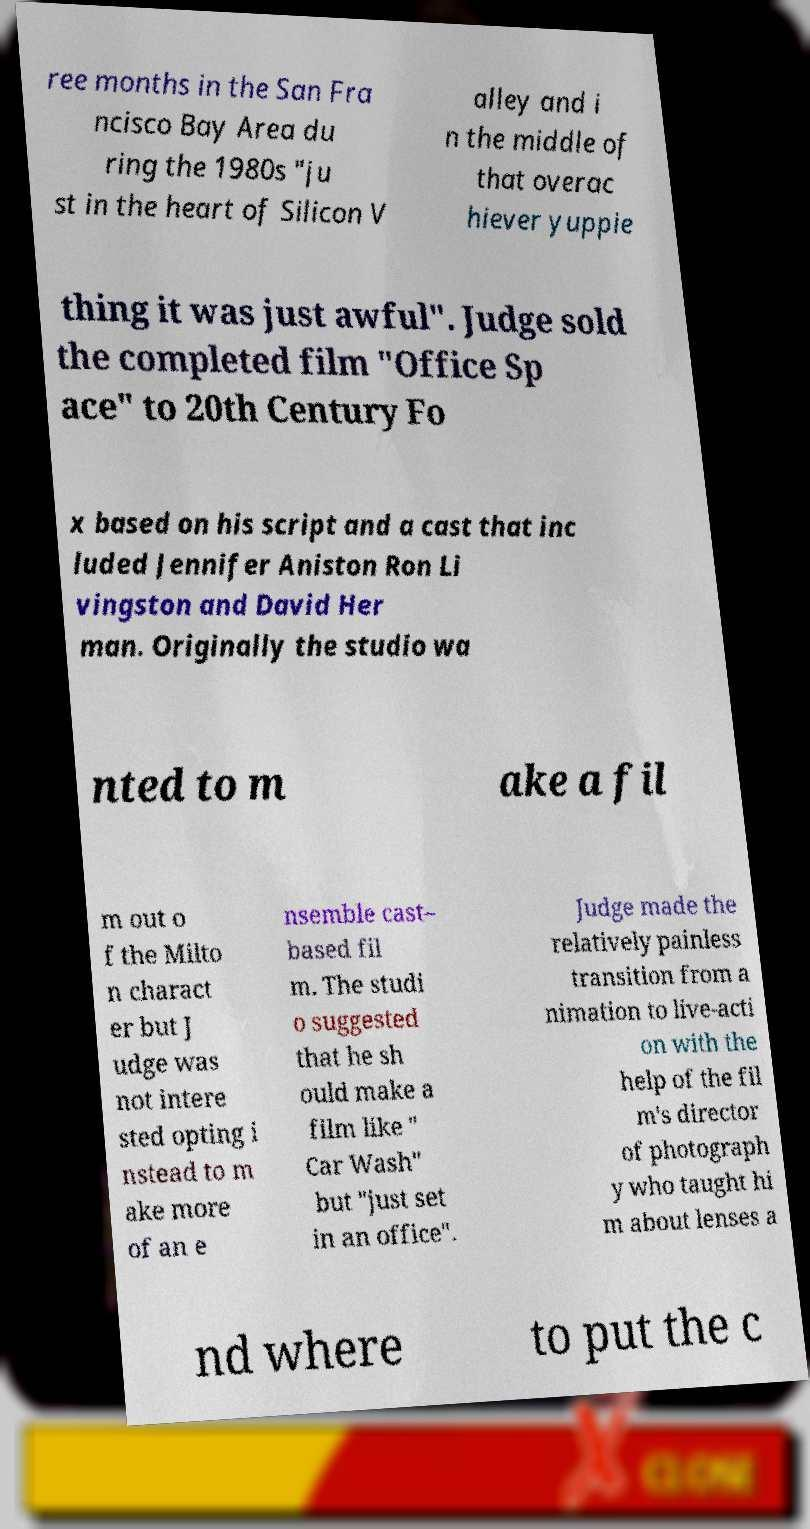There's text embedded in this image that I need extracted. Can you transcribe it verbatim? ree months in the San Fra ncisco Bay Area du ring the 1980s "ju st in the heart of Silicon V alley and i n the middle of that overac hiever yuppie thing it was just awful". Judge sold the completed film "Office Sp ace" to 20th Century Fo x based on his script and a cast that inc luded Jennifer Aniston Ron Li vingston and David Her man. Originally the studio wa nted to m ake a fil m out o f the Milto n charact er but J udge was not intere sted opting i nstead to m ake more of an e nsemble cast– based fil m. The studi o suggested that he sh ould make a film like " Car Wash" but "just set in an office". Judge made the relatively painless transition from a nimation to live-acti on with the help of the fil m's director of photograph y who taught hi m about lenses a nd where to put the c 